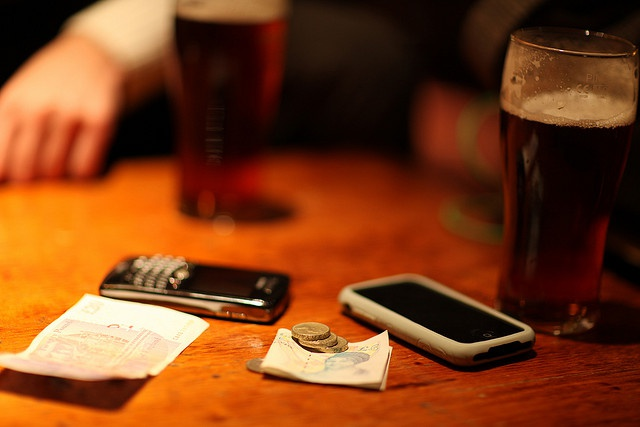Describe the objects in this image and their specific colors. I can see dining table in black, red, brown, and maroon tones, cup in black, maroon, and brown tones, people in black, orange, tan, and red tones, cup in black, maroon, and brown tones, and cell phone in black, tan, maroon, and brown tones in this image. 